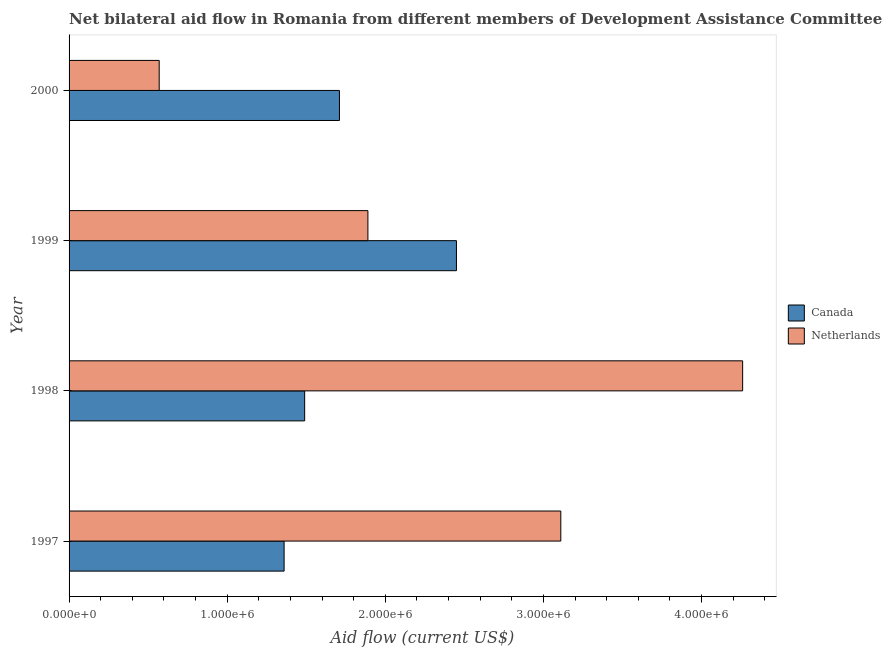How many different coloured bars are there?
Ensure brevity in your answer.  2. What is the amount of aid given by canada in 1998?
Offer a very short reply. 1.49e+06. Across all years, what is the maximum amount of aid given by canada?
Your answer should be compact. 2.45e+06. Across all years, what is the minimum amount of aid given by netherlands?
Give a very brief answer. 5.70e+05. What is the total amount of aid given by canada in the graph?
Ensure brevity in your answer.  7.01e+06. What is the difference between the amount of aid given by canada in 1997 and that in 1998?
Make the answer very short. -1.30e+05. What is the difference between the amount of aid given by canada in 1999 and the amount of aid given by netherlands in 1997?
Keep it short and to the point. -6.60e+05. What is the average amount of aid given by netherlands per year?
Ensure brevity in your answer.  2.46e+06. In the year 1997, what is the difference between the amount of aid given by netherlands and amount of aid given by canada?
Offer a terse response. 1.75e+06. What is the ratio of the amount of aid given by netherlands in 1997 to that in 1999?
Give a very brief answer. 1.65. Is the difference between the amount of aid given by canada in 1999 and 2000 greater than the difference between the amount of aid given by netherlands in 1999 and 2000?
Offer a terse response. No. What is the difference between the highest and the second highest amount of aid given by netherlands?
Provide a succinct answer. 1.15e+06. What is the difference between the highest and the lowest amount of aid given by canada?
Offer a terse response. 1.09e+06. In how many years, is the amount of aid given by netherlands greater than the average amount of aid given by netherlands taken over all years?
Give a very brief answer. 2. What does the 1st bar from the top in 2000 represents?
Your response must be concise. Netherlands. How many years are there in the graph?
Provide a succinct answer. 4. What is the difference between two consecutive major ticks on the X-axis?
Your answer should be compact. 1.00e+06. Does the graph contain any zero values?
Offer a terse response. No. Does the graph contain grids?
Offer a very short reply. No. Where does the legend appear in the graph?
Provide a short and direct response. Center right. What is the title of the graph?
Keep it short and to the point. Net bilateral aid flow in Romania from different members of Development Assistance Committee. Does "Number of arrivals" appear as one of the legend labels in the graph?
Offer a terse response. No. What is the label or title of the X-axis?
Give a very brief answer. Aid flow (current US$). What is the Aid flow (current US$) in Canada in 1997?
Your response must be concise. 1.36e+06. What is the Aid flow (current US$) in Netherlands in 1997?
Provide a short and direct response. 3.11e+06. What is the Aid flow (current US$) in Canada in 1998?
Your response must be concise. 1.49e+06. What is the Aid flow (current US$) in Netherlands in 1998?
Provide a succinct answer. 4.26e+06. What is the Aid flow (current US$) of Canada in 1999?
Offer a terse response. 2.45e+06. What is the Aid flow (current US$) of Netherlands in 1999?
Your answer should be compact. 1.89e+06. What is the Aid flow (current US$) in Canada in 2000?
Your response must be concise. 1.71e+06. What is the Aid flow (current US$) in Netherlands in 2000?
Offer a very short reply. 5.70e+05. Across all years, what is the maximum Aid flow (current US$) in Canada?
Keep it short and to the point. 2.45e+06. Across all years, what is the maximum Aid flow (current US$) of Netherlands?
Your answer should be compact. 4.26e+06. Across all years, what is the minimum Aid flow (current US$) in Canada?
Your response must be concise. 1.36e+06. Across all years, what is the minimum Aid flow (current US$) of Netherlands?
Your response must be concise. 5.70e+05. What is the total Aid flow (current US$) in Canada in the graph?
Ensure brevity in your answer.  7.01e+06. What is the total Aid flow (current US$) of Netherlands in the graph?
Make the answer very short. 9.83e+06. What is the difference between the Aid flow (current US$) of Netherlands in 1997 and that in 1998?
Make the answer very short. -1.15e+06. What is the difference between the Aid flow (current US$) in Canada in 1997 and that in 1999?
Ensure brevity in your answer.  -1.09e+06. What is the difference between the Aid flow (current US$) of Netherlands in 1997 and that in 1999?
Your answer should be compact. 1.22e+06. What is the difference between the Aid flow (current US$) of Canada in 1997 and that in 2000?
Ensure brevity in your answer.  -3.50e+05. What is the difference between the Aid flow (current US$) in Netherlands in 1997 and that in 2000?
Ensure brevity in your answer.  2.54e+06. What is the difference between the Aid flow (current US$) in Canada in 1998 and that in 1999?
Your answer should be compact. -9.60e+05. What is the difference between the Aid flow (current US$) in Netherlands in 1998 and that in 1999?
Offer a terse response. 2.37e+06. What is the difference between the Aid flow (current US$) of Canada in 1998 and that in 2000?
Make the answer very short. -2.20e+05. What is the difference between the Aid flow (current US$) in Netherlands in 1998 and that in 2000?
Provide a short and direct response. 3.69e+06. What is the difference between the Aid flow (current US$) in Canada in 1999 and that in 2000?
Keep it short and to the point. 7.40e+05. What is the difference between the Aid flow (current US$) of Netherlands in 1999 and that in 2000?
Provide a succinct answer. 1.32e+06. What is the difference between the Aid flow (current US$) of Canada in 1997 and the Aid flow (current US$) of Netherlands in 1998?
Ensure brevity in your answer.  -2.90e+06. What is the difference between the Aid flow (current US$) of Canada in 1997 and the Aid flow (current US$) of Netherlands in 1999?
Provide a succinct answer. -5.30e+05. What is the difference between the Aid flow (current US$) of Canada in 1997 and the Aid flow (current US$) of Netherlands in 2000?
Ensure brevity in your answer.  7.90e+05. What is the difference between the Aid flow (current US$) of Canada in 1998 and the Aid flow (current US$) of Netherlands in 1999?
Provide a succinct answer. -4.00e+05. What is the difference between the Aid flow (current US$) in Canada in 1998 and the Aid flow (current US$) in Netherlands in 2000?
Your answer should be very brief. 9.20e+05. What is the difference between the Aid flow (current US$) in Canada in 1999 and the Aid flow (current US$) in Netherlands in 2000?
Provide a succinct answer. 1.88e+06. What is the average Aid flow (current US$) in Canada per year?
Provide a short and direct response. 1.75e+06. What is the average Aid flow (current US$) of Netherlands per year?
Give a very brief answer. 2.46e+06. In the year 1997, what is the difference between the Aid flow (current US$) of Canada and Aid flow (current US$) of Netherlands?
Provide a succinct answer. -1.75e+06. In the year 1998, what is the difference between the Aid flow (current US$) of Canada and Aid flow (current US$) of Netherlands?
Offer a terse response. -2.77e+06. In the year 1999, what is the difference between the Aid flow (current US$) in Canada and Aid flow (current US$) in Netherlands?
Offer a very short reply. 5.60e+05. In the year 2000, what is the difference between the Aid flow (current US$) in Canada and Aid flow (current US$) in Netherlands?
Your answer should be very brief. 1.14e+06. What is the ratio of the Aid flow (current US$) of Canada in 1997 to that in 1998?
Offer a very short reply. 0.91. What is the ratio of the Aid flow (current US$) in Netherlands in 1997 to that in 1998?
Ensure brevity in your answer.  0.73. What is the ratio of the Aid flow (current US$) in Canada in 1997 to that in 1999?
Keep it short and to the point. 0.56. What is the ratio of the Aid flow (current US$) in Netherlands in 1997 to that in 1999?
Offer a very short reply. 1.65. What is the ratio of the Aid flow (current US$) in Canada in 1997 to that in 2000?
Ensure brevity in your answer.  0.8. What is the ratio of the Aid flow (current US$) of Netherlands in 1997 to that in 2000?
Keep it short and to the point. 5.46. What is the ratio of the Aid flow (current US$) of Canada in 1998 to that in 1999?
Offer a terse response. 0.61. What is the ratio of the Aid flow (current US$) of Netherlands in 1998 to that in 1999?
Provide a short and direct response. 2.25. What is the ratio of the Aid flow (current US$) in Canada in 1998 to that in 2000?
Provide a short and direct response. 0.87. What is the ratio of the Aid flow (current US$) in Netherlands in 1998 to that in 2000?
Offer a very short reply. 7.47. What is the ratio of the Aid flow (current US$) in Canada in 1999 to that in 2000?
Provide a short and direct response. 1.43. What is the ratio of the Aid flow (current US$) in Netherlands in 1999 to that in 2000?
Make the answer very short. 3.32. What is the difference between the highest and the second highest Aid flow (current US$) of Canada?
Offer a very short reply. 7.40e+05. What is the difference between the highest and the second highest Aid flow (current US$) of Netherlands?
Ensure brevity in your answer.  1.15e+06. What is the difference between the highest and the lowest Aid flow (current US$) of Canada?
Your answer should be compact. 1.09e+06. What is the difference between the highest and the lowest Aid flow (current US$) of Netherlands?
Keep it short and to the point. 3.69e+06. 